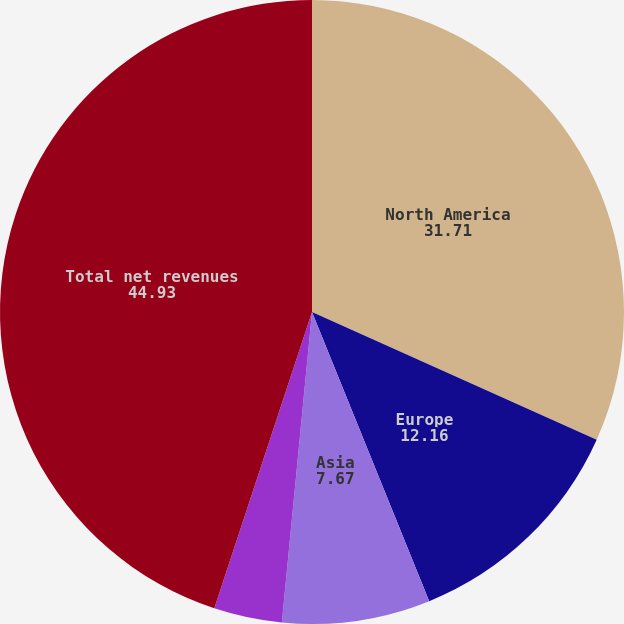Convert chart. <chart><loc_0><loc_0><loc_500><loc_500><pie_chart><fcel>North America<fcel>Europe<fcel>Asia<fcel>Other non-reportable segments<fcel>Total net revenues<nl><fcel>31.71%<fcel>12.16%<fcel>7.67%<fcel>3.53%<fcel>44.93%<nl></chart> 